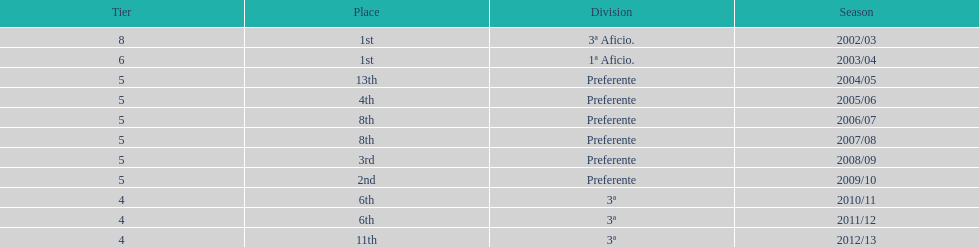Which division has the largest number of ranks? Preferente. 